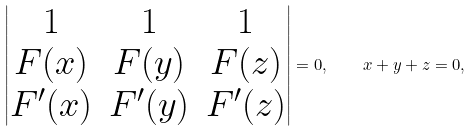<formula> <loc_0><loc_0><loc_500><loc_500>\begin{vmatrix} 1 & 1 & 1 \\ F ( x ) & F ( y ) & F ( z ) \\ F ^ { \prime } ( x ) & F ^ { \prime } ( y ) & F ^ { \prime } ( z ) \\ \end{vmatrix} = 0 , \quad x + y + z = 0 ,</formula> 